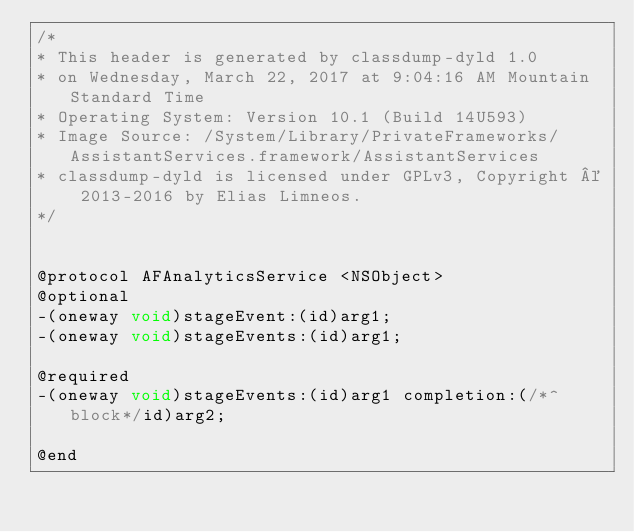<code> <loc_0><loc_0><loc_500><loc_500><_C_>/*
* This header is generated by classdump-dyld 1.0
* on Wednesday, March 22, 2017 at 9:04:16 AM Mountain Standard Time
* Operating System: Version 10.1 (Build 14U593)
* Image Source: /System/Library/PrivateFrameworks/AssistantServices.framework/AssistantServices
* classdump-dyld is licensed under GPLv3, Copyright © 2013-2016 by Elias Limneos.
*/


@protocol AFAnalyticsService <NSObject>
@optional
-(oneway void)stageEvent:(id)arg1;
-(oneway void)stageEvents:(id)arg1;

@required
-(oneway void)stageEvents:(id)arg1 completion:(/*^block*/id)arg2;

@end

</code> 